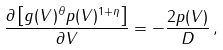<formula> <loc_0><loc_0><loc_500><loc_500>\frac { \partial \left [ g ( V ) ^ { \theta } p ( V ) ^ { 1 + \eta } \right ] } { \partial V } = - \frac { 2 p ( V ) } { D } \, ,</formula> 